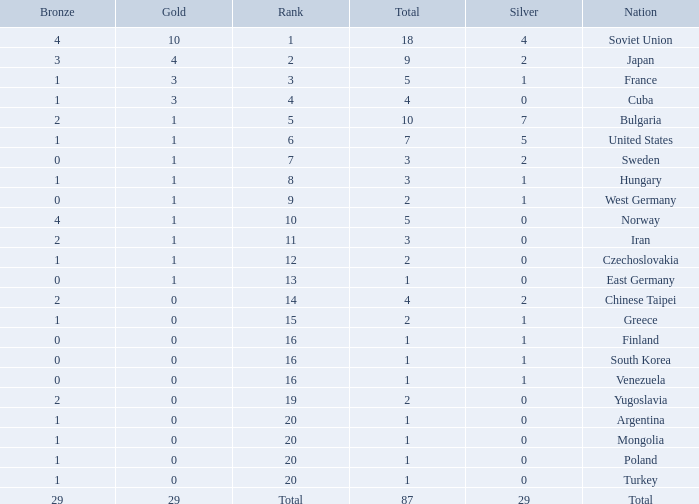What is the average number of bronze medals for total of all nations? 29.0. 